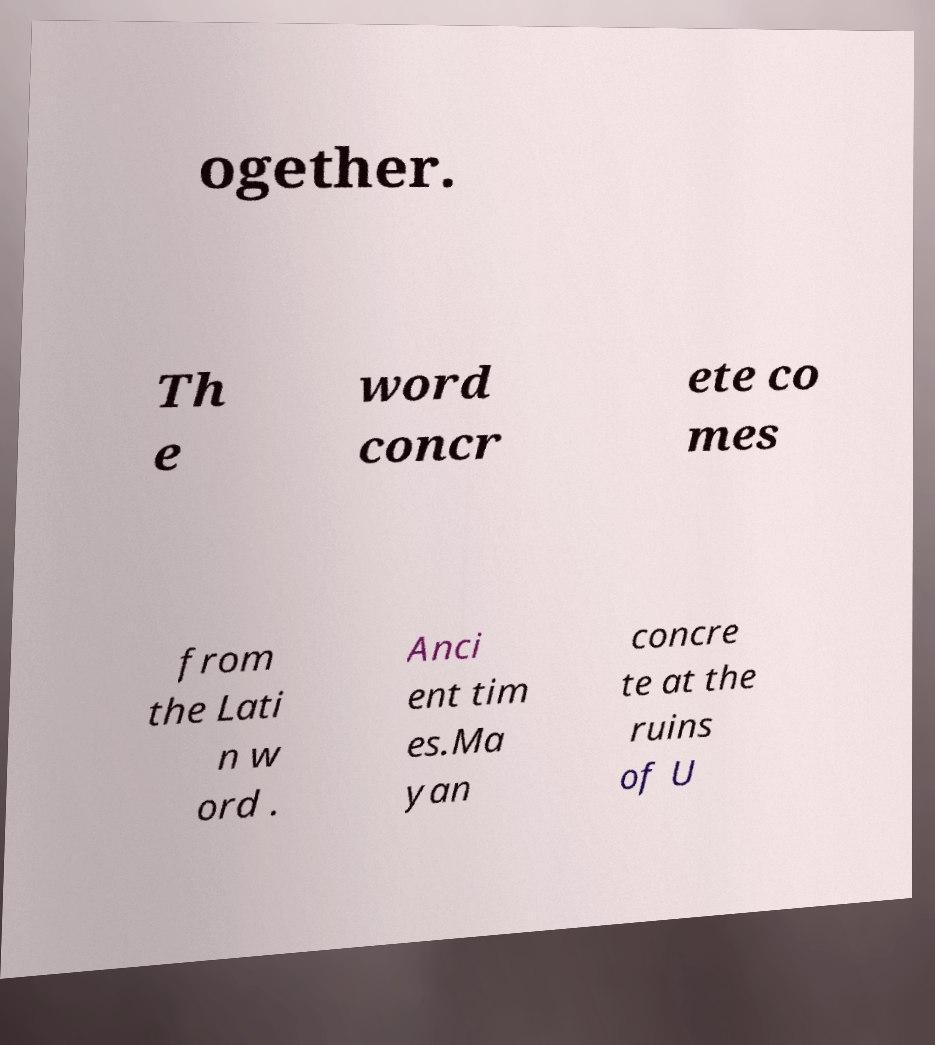Can you read and provide the text displayed in the image?This photo seems to have some interesting text. Can you extract and type it out for me? ogether. Th e word concr ete co mes from the Lati n w ord . Anci ent tim es.Ma yan concre te at the ruins of U 